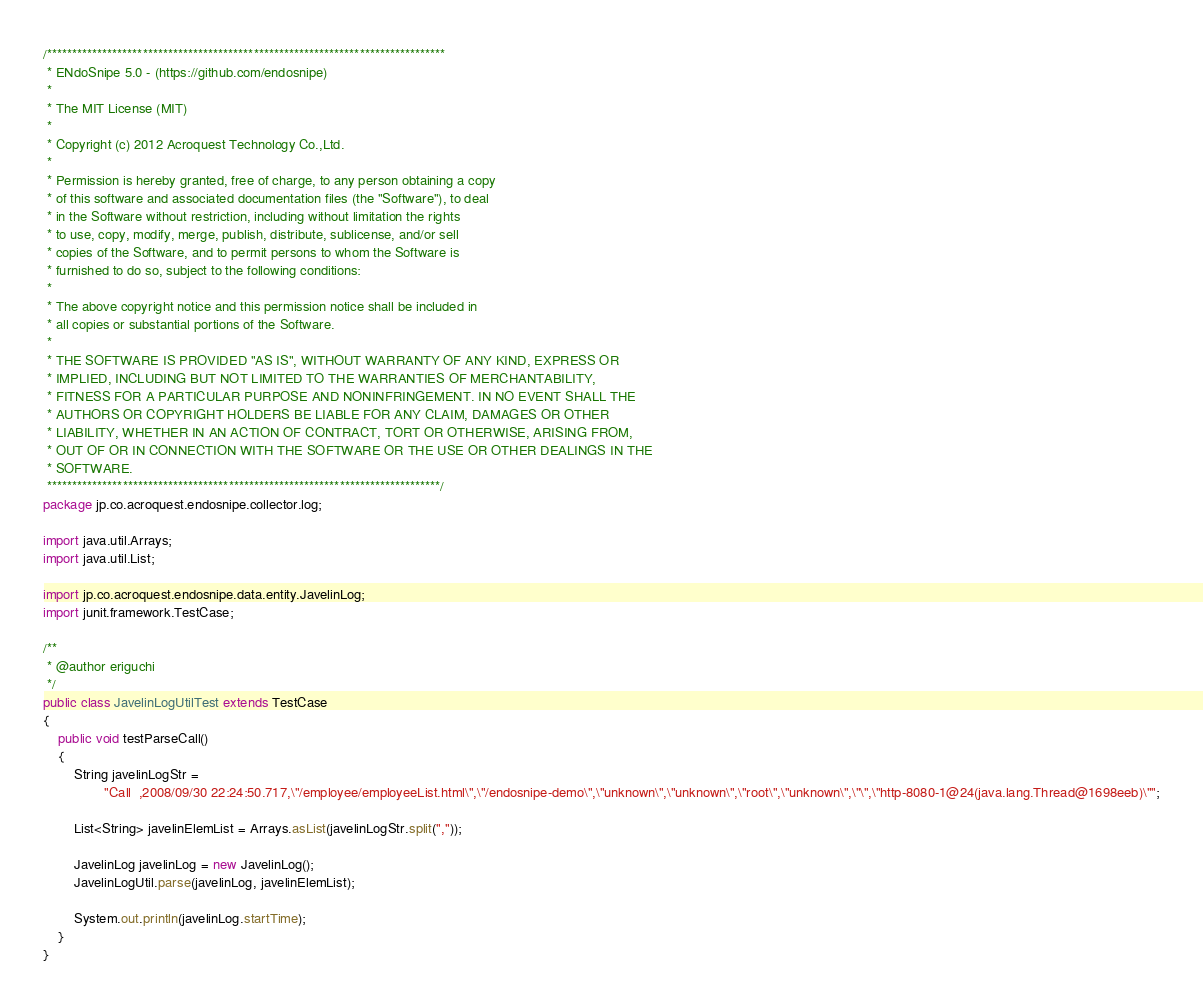<code> <loc_0><loc_0><loc_500><loc_500><_Java_>/*******************************************************************************
 * ENdoSnipe 5.0 - (https://github.com/endosnipe)
 * 
 * The MIT License (MIT)
 * 
 * Copyright (c) 2012 Acroquest Technology Co.,Ltd.
 * 
 * Permission is hereby granted, free of charge, to any person obtaining a copy
 * of this software and associated documentation files (the "Software"), to deal
 * in the Software without restriction, including without limitation the rights
 * to use, copy, modify, merge, publish, distribute, sublicense, and/or sell
 * copies of the Software, and to permit persons to whom the Software is
 * furnished to do so, subject to the following conditions:
 * 
 * The above copyright notice and this permission notice shall be included in
 * all copies or substantial portions of the Software.
 * 
 * THE SOFTWARE IS PROVIDED "AS IS", WITHOUT WARRANTY OF ANY KIND, EXPRESS OR
 * IMPLIED, INCLUDING BUT NOT LIMITED TO THE WARRANTIES OF MERCHANTABILITY,
 * FITNESS FOR A PARTICULAR PURPOSE AND NONINFRINGEMENT. IN NO EVENT SHALL THE
 * AUTHORS OR COPYRIGHT HOLDERS BE LIABLE FOR ANY CLAIM, DAMAGES OR OTHER
 * LIABILITY, WHETHER IN AN ACTION OF CONTRACT, TORT OR OTHERWISE, ARISING FROM,
 * OUT OF OR IN CONNECTION WITH THE SOFTWARE OR THE USE OR OTHER DEALINGS IN THE
 * SOFTWARE.
 ******************************************************************************/
package jp.co.acroquest.endosnipe.collector.log;

import java.util.Arrays;
import java.util.List;

import jp.co.acroquest.endosnipe.data.entity.JavelinLog;
import junit.framework.TestCase;

/**
 * @author eriguchi
 */
public class JavelinLogUtilTest extends TestCase
{
    public void testParseCall()
    {
        String javelinLogStr =
                "Call  ,2008/09/30 22:24:50.717,\"/employee/employeeList.html\",\"/endosnipe-demo\",\"unknown\",\"unknown\",\"root\",\"unknown\",\"\",\"http-8080-1@24(java.lang.Thread@1698eeb)\"";

        List<String> javelinElemList = Arrays.asList(javelinLogStr.split(","));

        JavelinLog javelinLog = new JavelinLog();
        JavelinLogUtil.parse(javelinLog, javelinElemList);

        System.out.println(javelinLog.startTime);
    }
}
</code> 